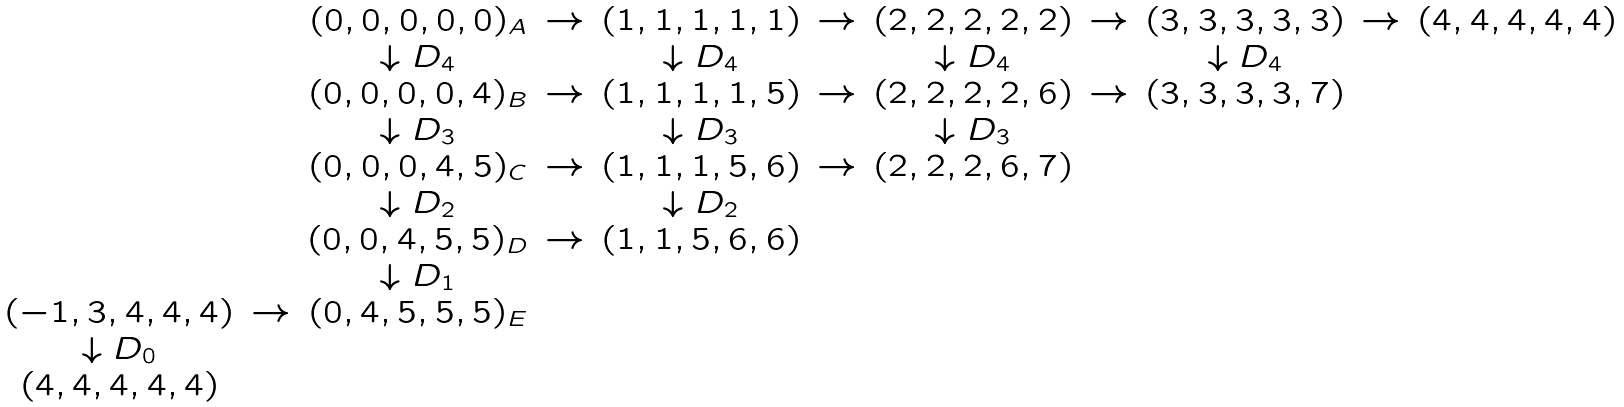<formula> <loc_0><loc_0><loc_500><loc_500>\begin{array} { c c c c c c c c c c c } & & ( 0 , 0 , 0 , 0 , 0 ) _ { A } & \to & ( 1 , 1 , 1 , 1 , 1 ) & \to & ( 2 , 2 , 2 , 2 , 2 ) & \to & ( 3 , 3 , 3 , 3 , 3 ) & \to & ( 4 , 4 , 4 , 4 , 4 ) \\ & & \downarrow D _ { 4 } & & \downarrow D _ { 4 } & & \downarrow D _ { 4 } & & \downarrow D _ { 4 } & & \\ & & ( 0 , 0 , 0 , 0 , 4 ) _ { B } & \to & ( 1 , 1 , 1 , 1 , 5 ) & \to & ( 2 , 2 , 2 , 2 , 6 ) & \to & ( 3 , 3 , 3 , 3 , 7 ) & & \\ & & \downarrow D _ { 3 } & & \downarrow D _ { 3 } & & \downarrow D _ { 3 } & & & & \\ & & ( 0 , 0 , 0 , 4 , 5 ) _ { C } & \to & ( 1 , 1 , 1 , 5 , 6 ) & \to & ( 2 , 2 , 2 , 6 , 7 ) & & & & \\ & & \downarrow D _ { 2 } & & \downarrow D _ { 2 } & & & & & & \\ & & ( 0 , 0 , 4 , 5 , 5 ) _ { D } & \to & ( 1 , 1 , 5 , 6 , 6 ) & & & & & & \\ & & \downarrow D _ { 1 } & & & & & & & & \\ ( - 1 , 3 , 4 , 4 , 4 ) & \to & ( 0 , 4 , 5 , 5 , 5 ) _ { E } & & & & & & & & \\ \downarrow D _ { 0 } & & & & & & & & & & \\ ( 4 , 4 , 4 , 4 , 4 ) & & & & & & & & & & \end{array}</formula> 